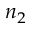Convert formula to latex. <formula><loc_0><loc_0><loc_500><loc_500>n _ { 2 }</formula> 